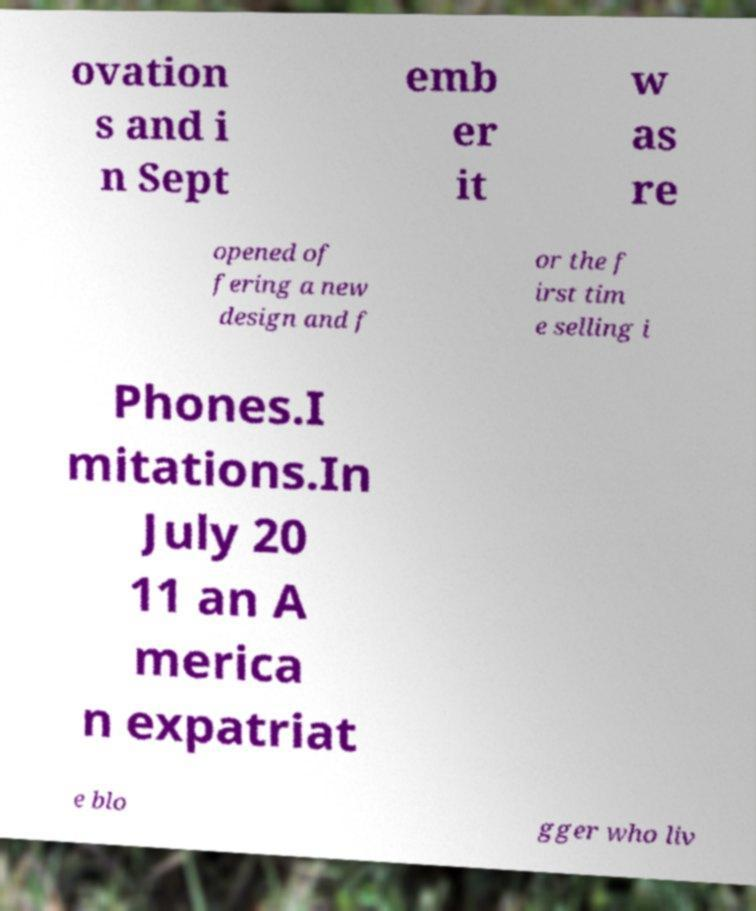There's text embedded in this image that I need extracted. Can you transcribe it verbatim? ovation s and i n Sept emb er it w as re opened of fering a new design and f or the f irst tim e selling i Phones.I mitations.In July 20 11 an A merica n expatriat e blo gger who liv 